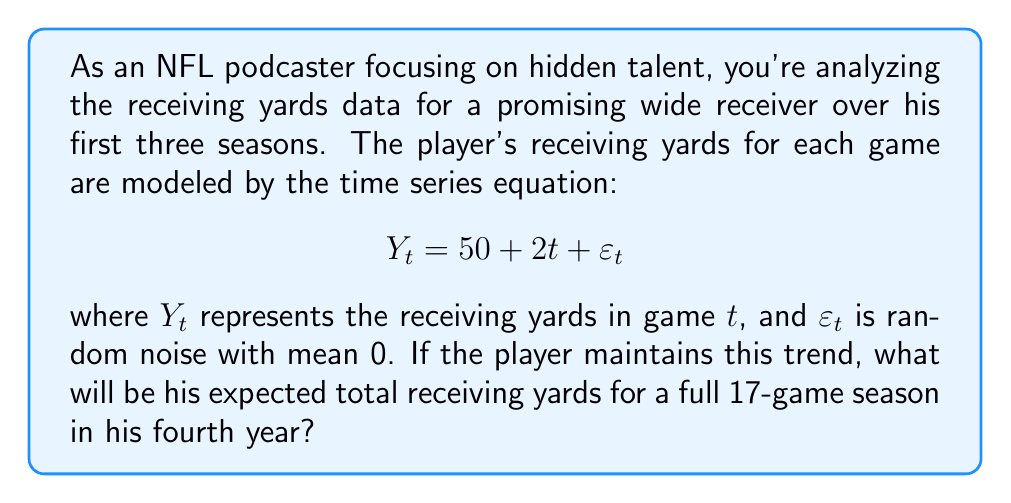Give your solution to this math problem. To solve this problem, we need to follow these steps:

1) First, we need to understand the time series equation:
   $$Y_t = 50 + 2t + \varepsilon_t$$
   This equation suggests that the player's receiving yards are increasing linearly over time, with a base of 50 yards and an increase of 2 yards per game.

2) The $\varepsilon_t$ term represents random noise with a mean of 0, so for calculating the expected value, we can ignore this term.

3) In the fourth season, the games will be numbered from 49 to 65 (as there are 16 games per season for the first three seasons, and we're looking at the 17 games of the fourth season).

4) We need to calculate the expected yards for each game and then sum them up:

   Game 49: $E(Y_{49}) = 50 + 2(49) = 148$
   Game 50: $E(Y_{50}) = 50 + 2(50) = 150$
   ...
   Game 65: $E(Y_{65}) = 50 + 2(65) = 180$

5) To find the total, we can use the formula for the sum of an arithmetic sequence:
   $$S_n = \frac{n}{2}(a_1 + a_n)$$
   where $n$ is the number of terms, $a_1$ is the first term, and $a_n$ is the last term.

6) In this case:
   $n = 17$ (number of games)
   $a_1 = 148$ (yards in first game of season)
   $a_{17} = 180$ (yards in last game of season)

7) Plugging into the formula:
   $$S_{17} = \frac{17}{2}(148 + 180) = \frac{17}{2}(328) = 17(164) = 2788$$

Therefore, the expected total receiving yards for the 17-game season is 2,788 yards.
Answer: 2,788 yards 